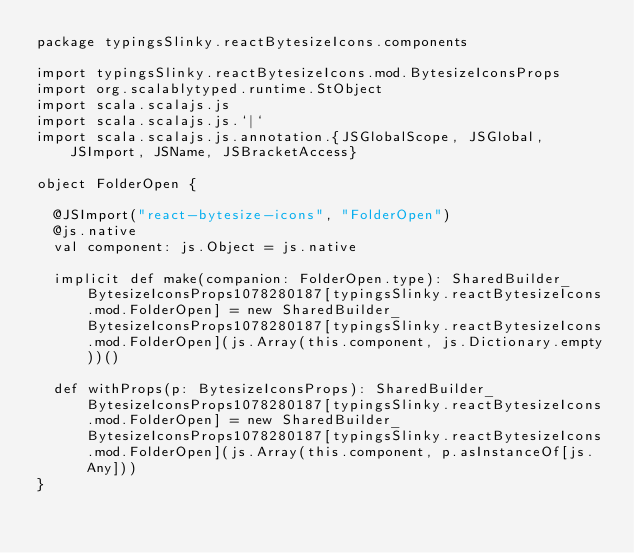Convert code to text. <code><loc_0><loc_0><loc_500><loc_500><_Scala_>package typingsSlinky.reactBytesizeIcons.components

import typingsSlinky.reactBytesizeIcons.mod.BytesizeIconsProps
import org.scalablytyped.runtime.StObject
import scala.scalajs.js
import scala.scalajs.js.`|`
import scala.scalajs.js.annotation.{JSGlobalScope, JSGlobal, JSImport, JSName, JSBracketAccess}

object FolderOpen {
  
  @JSImport("react-bytesize-icons", "FolderOpen")
  @js.native
  val component: js.Object = js.native
  
  implicit def make(companion: FolderOpen.type): SharedBuilder_BytesizeIconsProps1078280187[typingsSlinky.reactBytesizeIcons.mod.FolderOpen] = new SharedBuilder_BytesizeIconsProps1078280187[typingsSlinky.reactBytesizeIcons.mod.FolderOpen](js.Array(this.component, js.Dictionary.empty))()
  
  def withProps(p: BytesizeIconsProps): SharedBuilder_BytesizeIconsProps1078280187[typingsSlinky.reactBytesizeIcons.mod.FolderOpen] = new SharedBuilder_BytesizeIconsProps1078280187[typingsSlinky.reactBytesizeIcons.mod.FolderOpen](js.Array(this.component, p.asInstanceOf[js.Any]))
}
</code> 